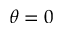<formula> <loc_0><loc_0><loc_500><loc_500>\theta = 0</formula> 